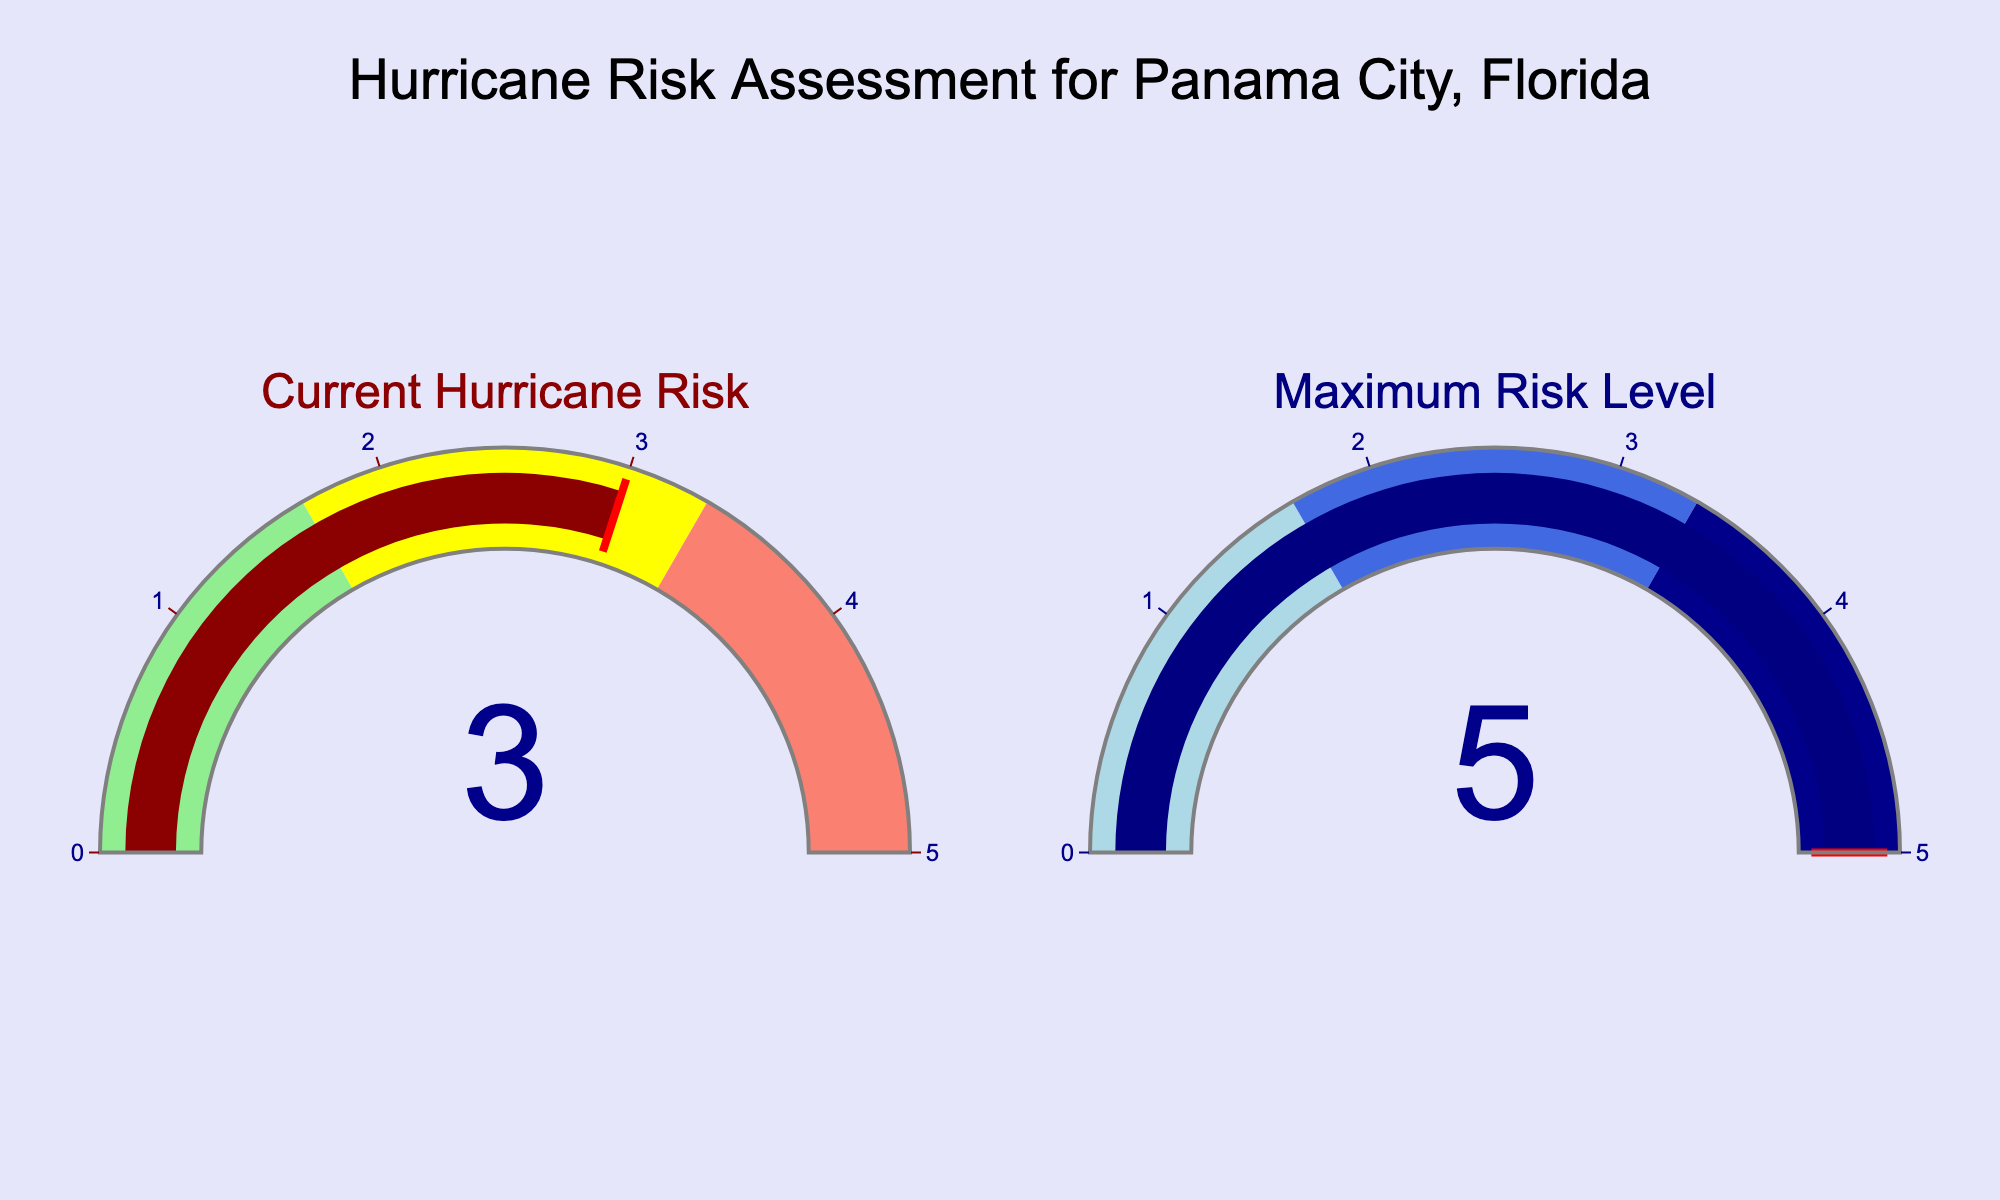What's the current hurricane risk level for Panama City? The figure displays a gauge titled "Current Hurricane Risk" that indicates the risk level. The needle points to a value of 3.
Answer: 3 What's the maximum risk level represented in the chart? The second gauge is titled "Maximum Risk Level" and the needle points to a value of 5.
Answer: 5 What range does the hurricane risk level gauge cover? The gauge for "Current Hurricane Risk" has an axis that covers a range from 0 to 5, indicated by the settings in the figure.
Answer: 0 to 5 How does the current hurricane risk compare to the maximum risk level? The value on the "Current Hurricane Risk" gauge is 3, while the "Maximum Risk Level" gauge shows 5. Since 3 is less than 5, the current risk is lower than the maximum risk level.
Answer: Lower What color range does the current hurricane risk fall under? The "Current Hurricane Risk" gauge has color-coded sections: light green (0-1.67), yellow (1.67-3.33), and salmon (3.33-5). The current value is 3, which falls in the yellow range.
Answer: Yellow What does the red line indicate on each gauge? The red line in the gauge indicates the threshold beyond which the risk is considered high. On the "Current Hurricane Risk" gauge, the red line is placed at 3, and on the "Maximum Risk Level" gauge, it is placed at 5.
Answer: Threshold Is Panama City currently at or above the highest risk level? The "Current Hurricane Risk" value is 3, which is below the highest risk level of 5 shown in the "Maximum Risk Level" gauge.
Answer: No 